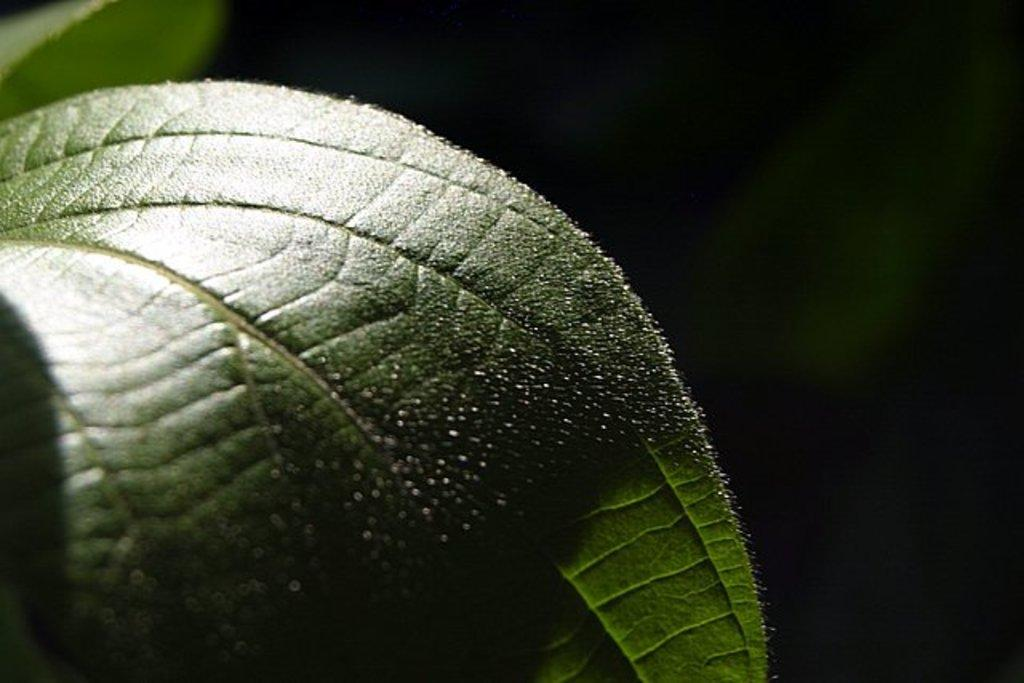What type of vegetation is present in the image? There are green-colored leaves in the image. What is the color of the background in the image? The background of the image is dark. What type of blood can be seen on the quiet snail in the image? There is no snail, blood, or any reference to quietness in the image; it only features green-colored leaves and a dark background. 